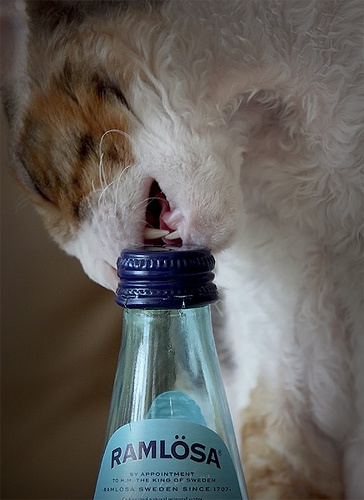Describe the objects in this image and their specific colors. I can see cat in black, gray, darkgray, and maroon tones and bottle in black, gray, and blue tones in this image. 